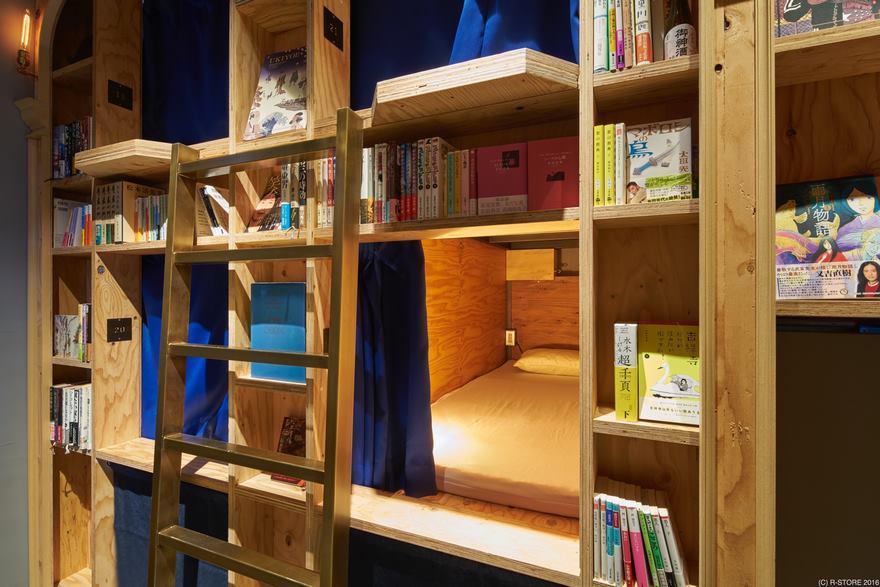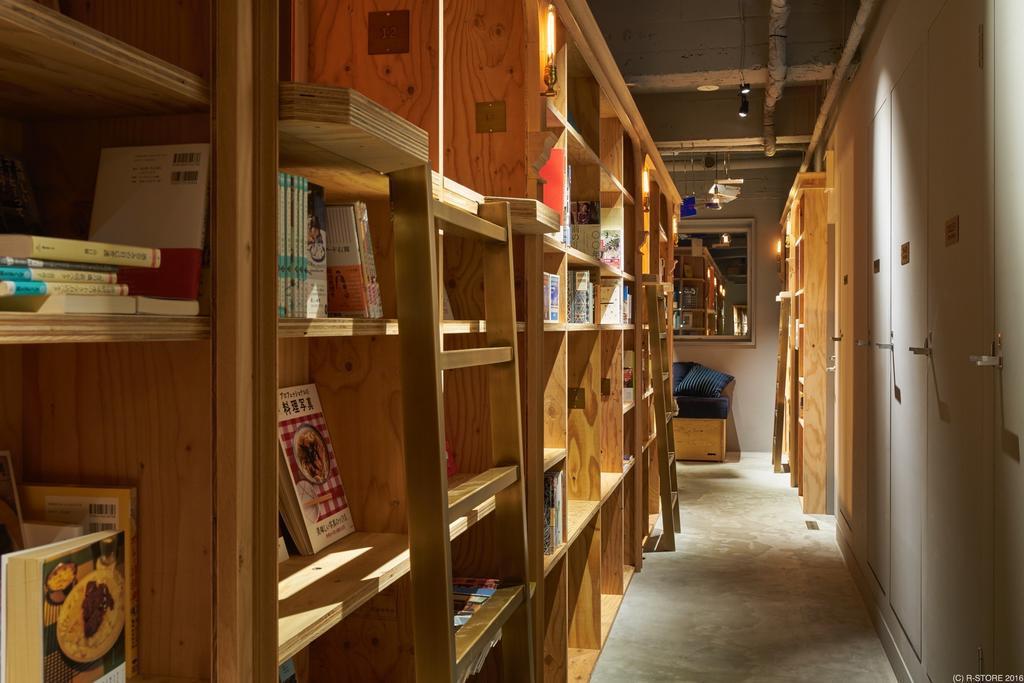The first image is the image on the left, the second image is the image on the right. Examine the images to the left and right. Is the description "A blue seating area sits near the books in the image on the right." accurate? Answer yes or no. No. The first image is the image on the left, the second image is the image on the right. Given the left and right images, does the statement "In one scene, one person is sitting and reading on a blue cushioned bench in front of raw-wood shelves and near a ladder." hold true? Answer yes or no. No. 